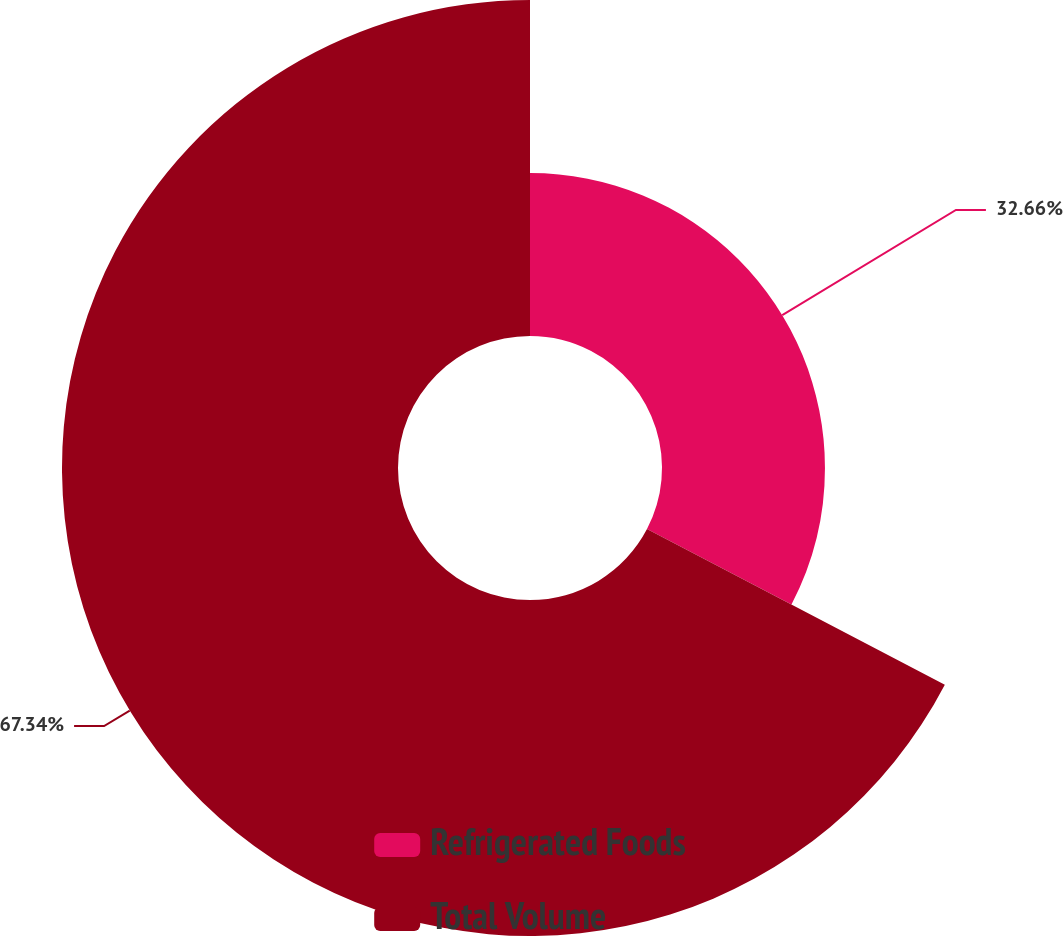Convert chart. <chart><loc_0><loc_0><loc_500><loc_500><pie_chart><fcel>Refrigerated Foods<fcel>Total Volume<nl><fcel>32.66%<fcel>67.34%<nl></chart> 